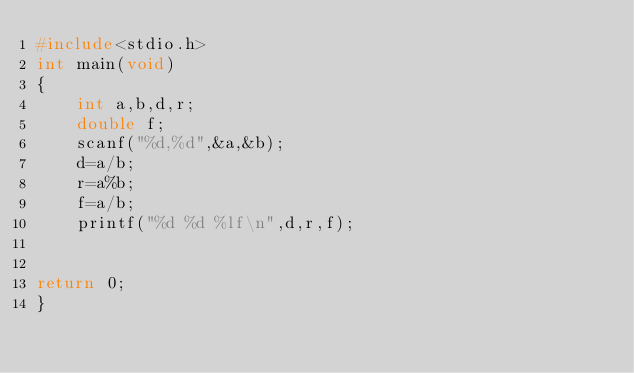Convert code to text. <code><loc_0><loc_0><loc_500><loc_500><_C_>#include<stdio.h>
int main(void)
{
	int a,b,d,r;
	double f;
	scanf("%d,%d",&a,&b);
	d=a/b;
	r=a%b;
	f=a/b;
	printf("%d %d %lf\n",d,r,f);
	

return 0;
}</code> 